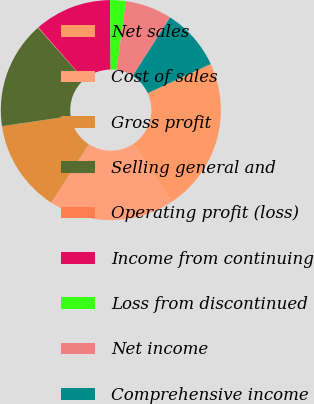Convert chart to OTSL. <chart><loc_0><loc_0><loc_500><loc_500><pie_chart><fcel>Net sales<fcel>Cost of sales<fcel>Gross profit<fcel>Selling general and<fcel>Operating profit (loss)<fcel>Income from continuing<fcel>Loss from discontinued<fcel>Net income<fcel>Comprehensive income<nl><fcel>22.57%<fcel>18.41%<fcel>13.57%<fcel>15.82%<fcel>0.08%<fcel>11.32%<fcel>2.33%<fcel>6.83%<fcel>9.07%<nl></chart> 